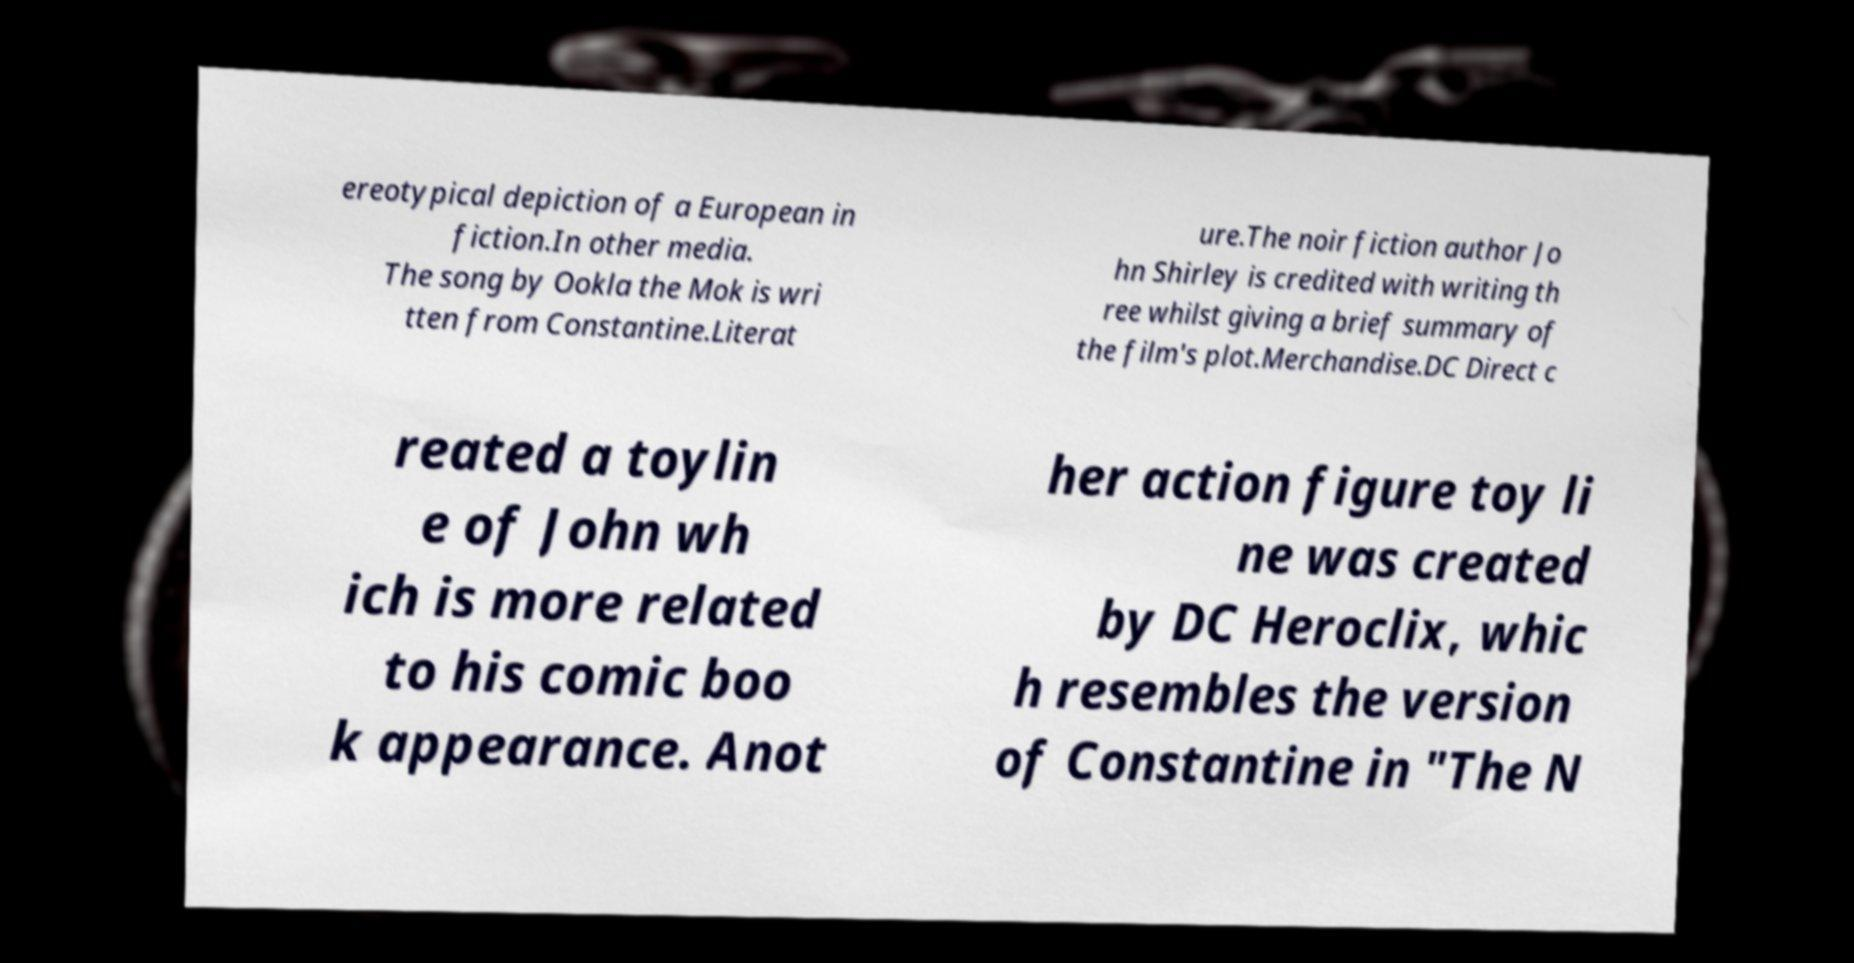What messages or text are displayed in this image? I need them in a readable, typed format. ereotypical depiction of a European in fiction.In other media. The song by Ookla the Mok is wri tten from Constantine.Literat ure.The noir fiction author Jo hn Shirley is credited with writing th ree whilst giving a brief summary of the film's plot.Merchandise.DC Direct c reated a toylin e of John wh ich is more related to his comic boo k appearance. Anot her action figure toy li ne was created by DC Heroclix, whic h resembles the version of Constantine in "The N 